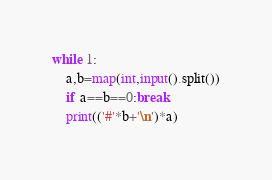<code> <loc_0><loc_0><loc_500><loc_500><_Python_>while 1:
    a,b=map(int,input().split())
    if a==b==0:break
    print(('#'*b+'\n')*a)
</code> 